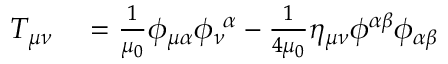Convert formula to latex. <formula><loc_0><loc_0><loc_500><loc_500>\begin{array} { r l } { T _ { \mu \nu } } & = \frac { 1 } { \mu _ { 0 } } \phi _ { \mu \alpha } \phi _ { \nu } ^ { \ \alpha } - \frac { 1 } { 4 \mu _ { 0 } } \eta _ { \mu \nu } \phi ^ { \alpha \beta } \phi _ { \alpha \beta } } \end{array}</formula> 